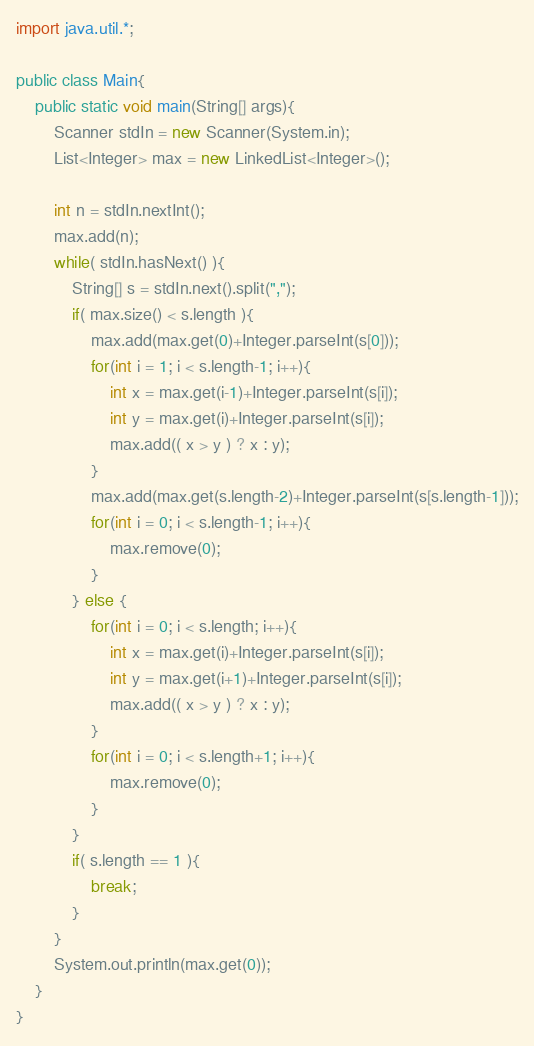Convert code to text. <code><loc_0><loc_0><loc_500><loc_500><_Java_>import java.util.*;

public class Main{
	public static void main(String[] args){
		Scanner stdIn = new Scanner(System.in);
		List<Integer> max = new LinkedList<Integer>();
		
		int n = stdIn.nextInt();
		max.add(n);		
		while( stdIn.hasNext() ){
			String[] s = stdIn.next().split(",");
			if( max.size() < s.length ){
				max.add(max.get(0)+Integer.parseInt(s[0]));
				for(int i = 1; i < s.length-1; i++){
					int x = max.get(i-1)+Integer.parseInt(s[i]);
					int y = max.get(i)+Integer.parseInt(s[i]);
					max.add(( x > y ) ? x : y);
				}
				max.add(max.get(s.length-2)+Integer.parseInt(s[s.length-1]));
				for(int i = 0; i < s.length-1; i++){
					max.remove(0);
				}
			} else {
				for(int i = 0; i < s.length; i++){
					int x = max.get(i)+Integer.parseInt(s[i]);
					int y = max.get(i+1)+Integer.parseInt(s[i]);
					max.add(( x > y ) ? x : y);
				}
				for(int i = 0; i < s.length+1; i++){
					max.remove(0);
				}
			}
			if( s.length == 1 ){
				break;
			}
		}
		System.out.println(max.get(0));
	}
}</code> 